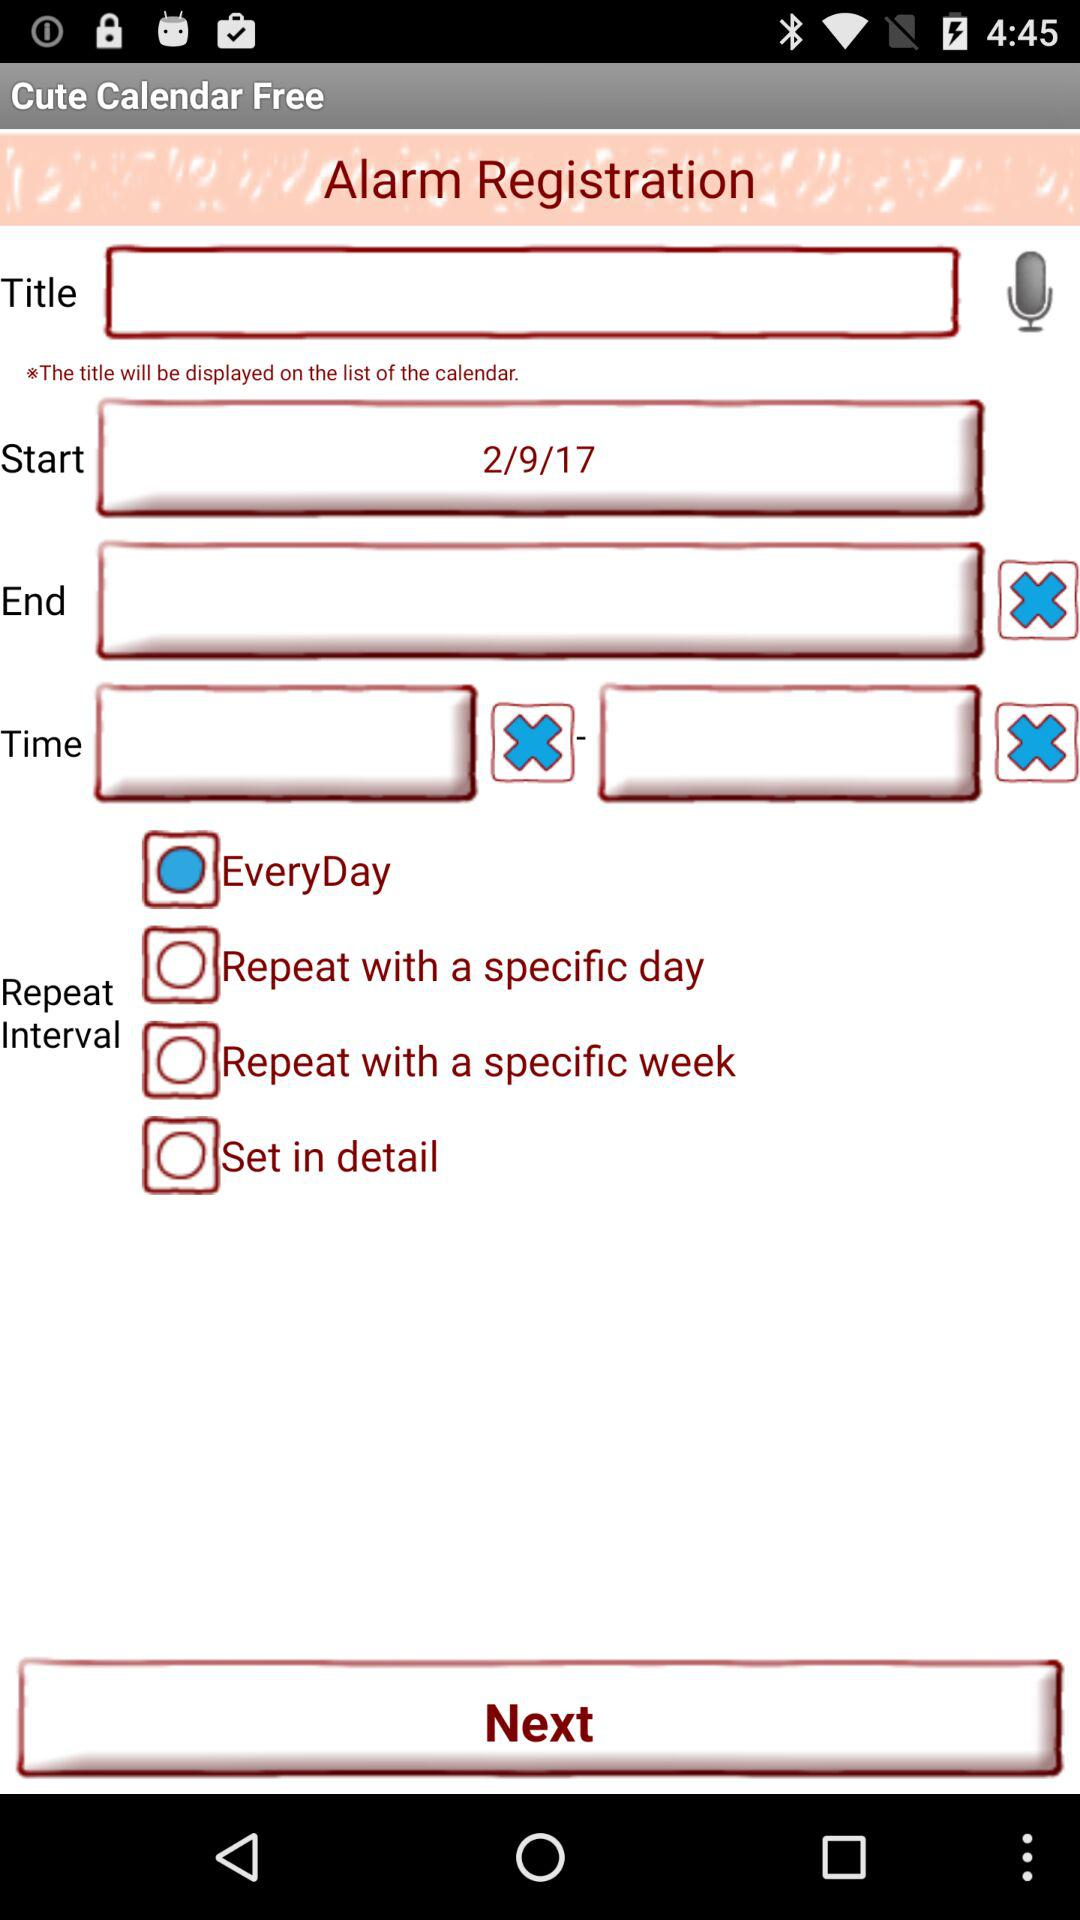What is the status of the "Set in detail"? The status is off. 